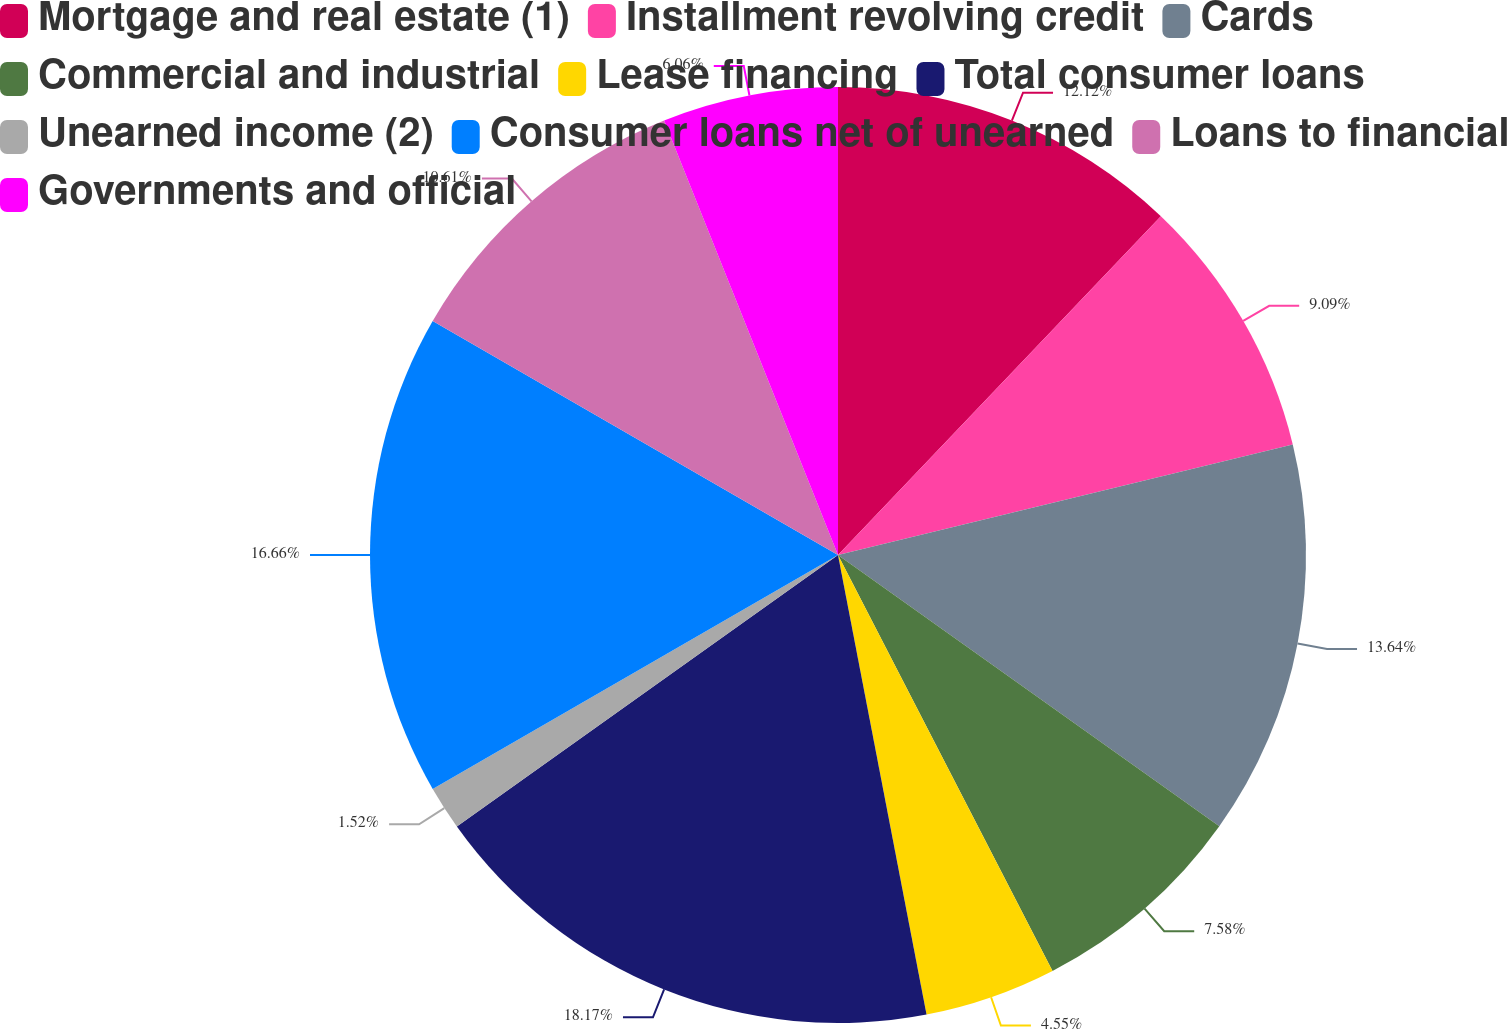Convert chart. <chart><loc_0><loc_0><loc_500><loc_500><pie_chart><fcel>Mortgage and real estate (1)<fcel>Installment revolving credit<fcel>Cards<fcel>Commercial and industrial<fcel>Lease financing<fcel>Total consumer loans<fcel>Unearned income (2)<fcel>Consumer loans net of unearned<fcel>Loans to financial<fcel>Governments and official<nl><fcel>12.12%<fcel>9.09%<fcel>13.64%<fcel>7.58%<fcel>4.55%<fcel>18.18%<fcel>1.52%<fcel>16.67%<fcel>10.61%<fcel>6.06%<nl></chart> 